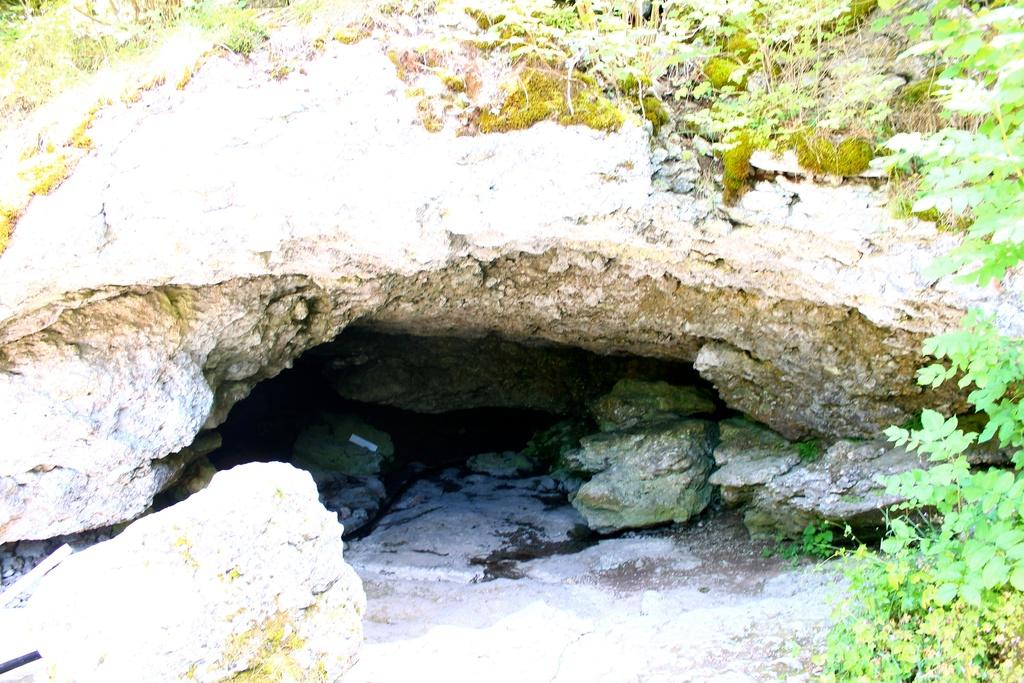What type of natural elements can be seen in the image? There are rocks and plants in the image. Can you describe the rocks in the image? The rocks in the image are likely solid and immovable. What type of plants are present in the image? The plants in the image could be various types, such as trees, bushes, or flowers. What type of cave can be seen in the image? There is no cave present in the image; it only features rocks and plants. What force is responsible for the plants growing in the image? The image does not provide information about the force responsible for the plants growing; it only shows their presence. 